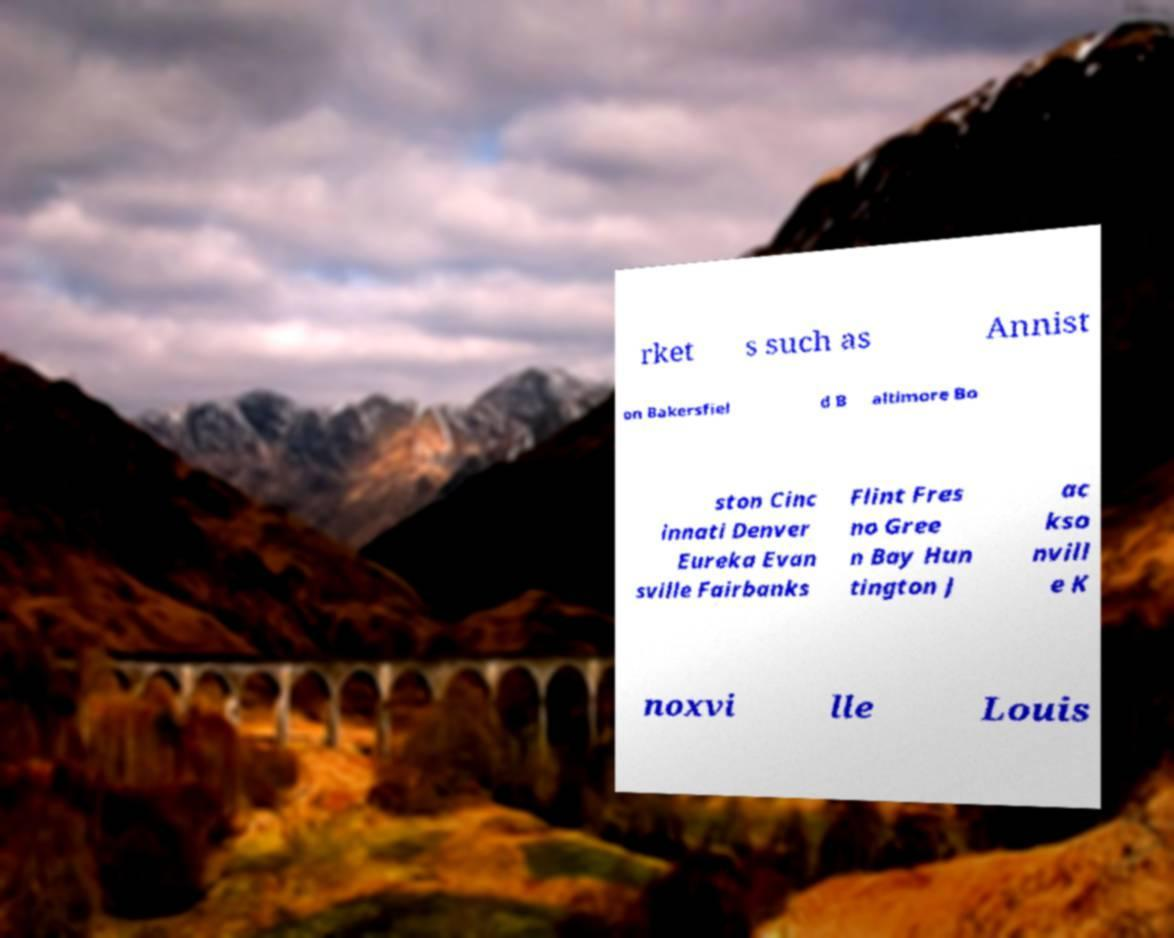Could you extract and type out the text from this image? rket s such as Annist on Bakersfiel d B altimore Bo ston Cinc innati Denver Eureka Evan sville Fairbanks Flint Fres no Gree n Bay Hun tington J ac kso nvill e K noxvi lle Louis 